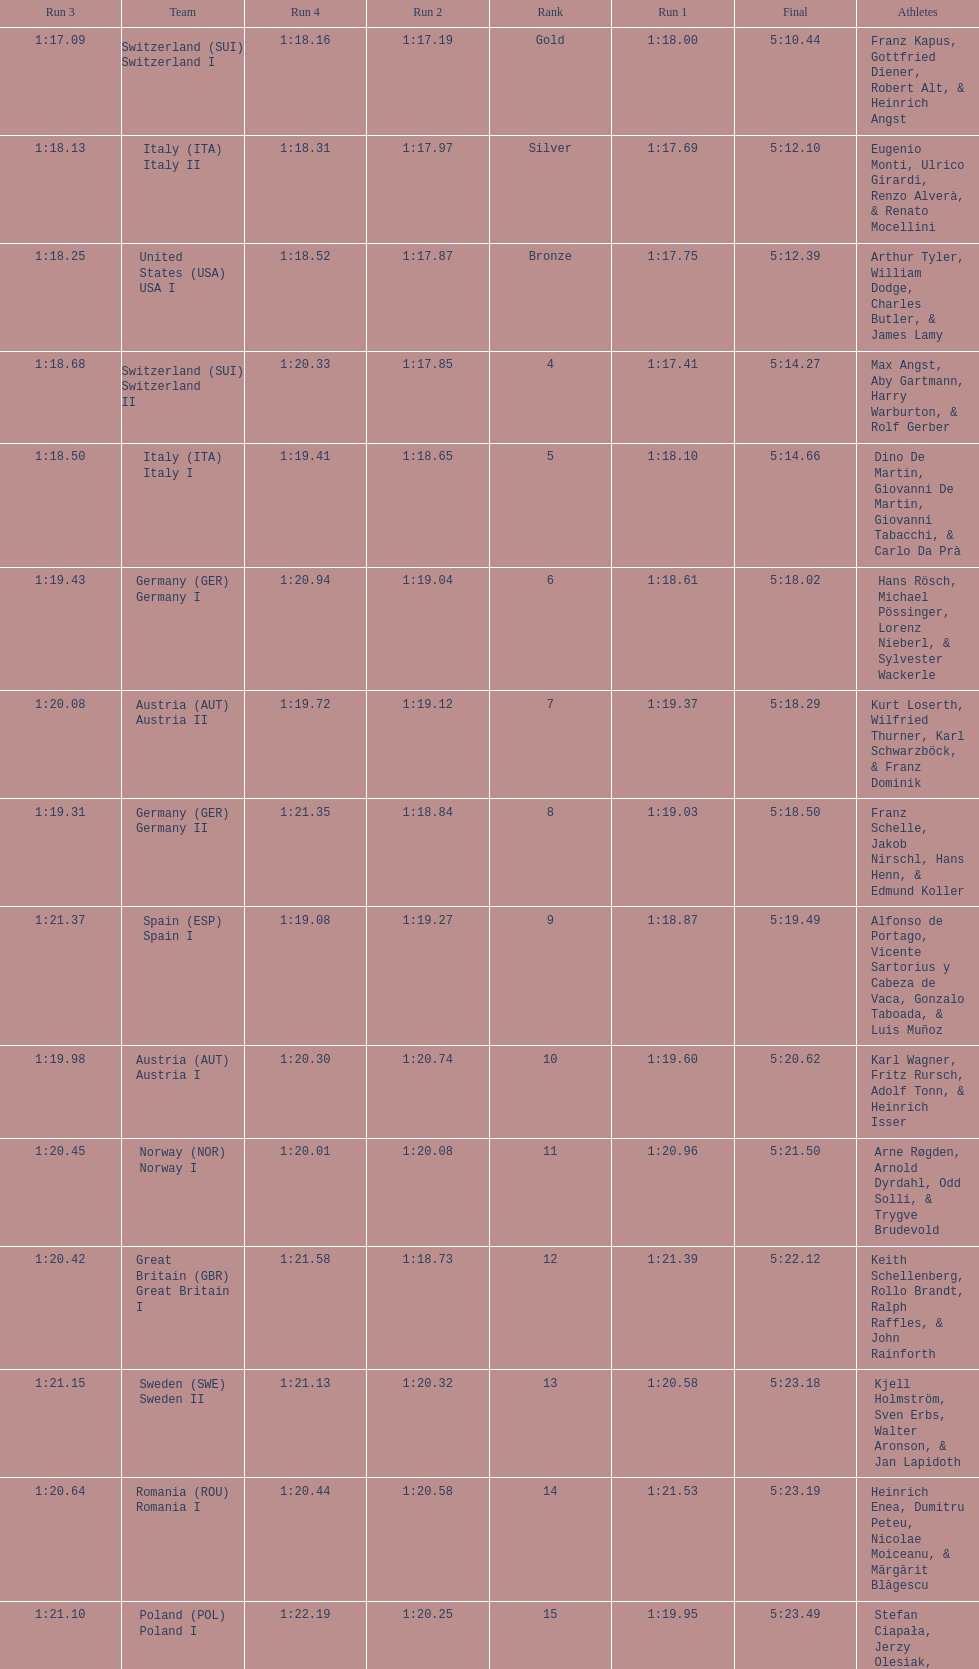Who is the previous team to italy (ita) italy ii? Switzerland (SUI) Switzerland I. 